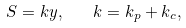<formula> <loc_0><loc_0><loc_500><loc_500>S = k y , \quad k = k _ { p } + k _ { c } ,</formula> 